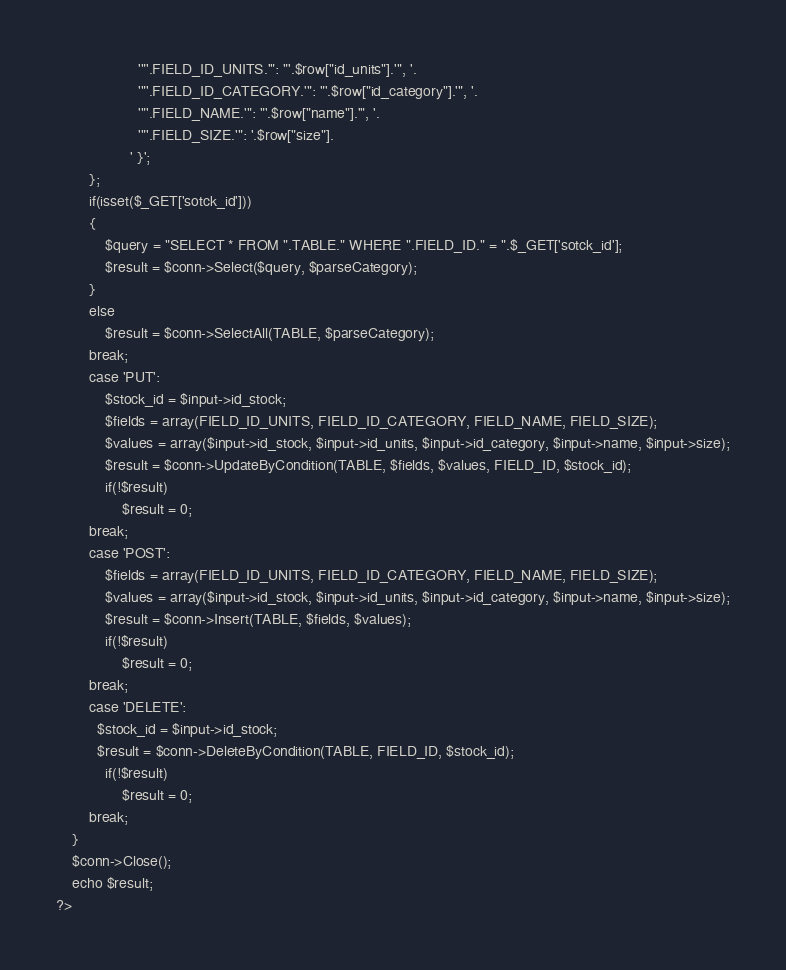<code> <loc_0><loc_0><loc_500><loc_500><_PHP_>                    '"'.FIELD_ID_UNITS.'": "'.$row["id_units"].'", '.
                    '"'.FIELD_ID_CATEGORY.'": "'.$row["id_category"].'", '.
                    '"'.FIELD_NAME.'": "'.$row["name"].'", '.
                    '"'.FIELD_SIZE.'": '.$row["size"].
                  ' }';
        };
        if(isset($_GET['sotck_id']))
        {
            $query = "SELECT * FROM ".TABLE." WHERE ".FIELD_ID." = ".$_GET['sotck_id'];
            $result = $conn->Select($query, $parseCategory);
        }
        else    
            $result = $conn->SelectAll(TABLE, $parseCategory);
        break;
        case 'PUT':
            $stock_id = $input->id_stock;
            $fields = array(FIELD_ID_UNITS, FIELD_ID_CATEGORY, FIELD_NAME, FIELD_SIZE);
            $values = array($input->id_stock, $input->id_units, $input->id_category, $input->name, $input->size);
            $result = $conn->UpdateByCondition(TABLE, $fields, $values, FIELD_ID, $stock_id);
            if(!$result)
                $result = 0;    
        break;
        case 'POST':
            $fields = array(FIELD_ID_UNITS, FIELD_ID_CATEGORY, FIELD_NAME, FIELD_SIZE);
            $values = array($input->id_stock, $input->id_units, $input->id_category, $input->name, $input->size);
            $result = $conn->Insert(TABLE, $fields, $values);
            if(!$result)
                $result = 0;
        break;
        case 'DELETE':
          $stock_id = $input->id_stock;
          $result = $conn->DeleteByCondition(TABLE, FIELD_ID, $stock_id);
            if(!$result)
                $result = 0;
        break;
    }
    $conn->Close();
    echo $result;
?></code> 